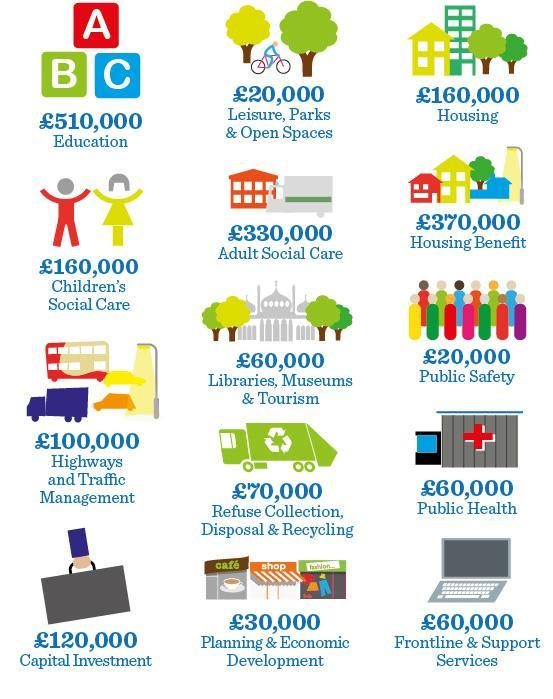what is written on the shop boards in Planning & Economic Development
Answer the question with a short phrase. cafe, shop, fashion What is the man riding in leisure, parks & open spaces, cycle or car cycle What is the colour of the suitcase, grey or white grey What is the total amount in pounds for housing benefit and public safety 390,000 What is the total amount in pounds in Public Health and Frontline & Support Services 120,000 